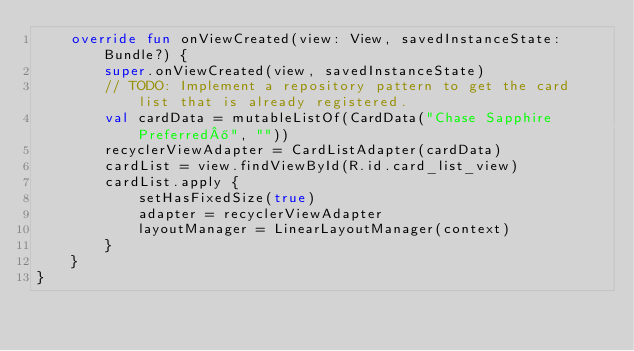<code> <loc_0><loc_0><loc_500><loc_500><_Kotlin_>    override fun onViewCreated(view: View, savedInstanceState: Bundle?) {
        super.onViewCreated(view, savedInstanceState)
        // TODO: Implement a repository pattern to get the card list that is already registered.
        val cardData = mutableListOf(CardData("Chase Sapphire Preferred®", ""))
        recyclerViewAdapter = CardListAdapter(cardData)
        cardList = view.findViewById(R.id.card_list_view)
        cardList.apply {
            setHasFixedSize(true)
            adapter = recyclerViewAdapter
            layoutManager = LinearLayoutManager(context)
        }
    }
}
</code> 